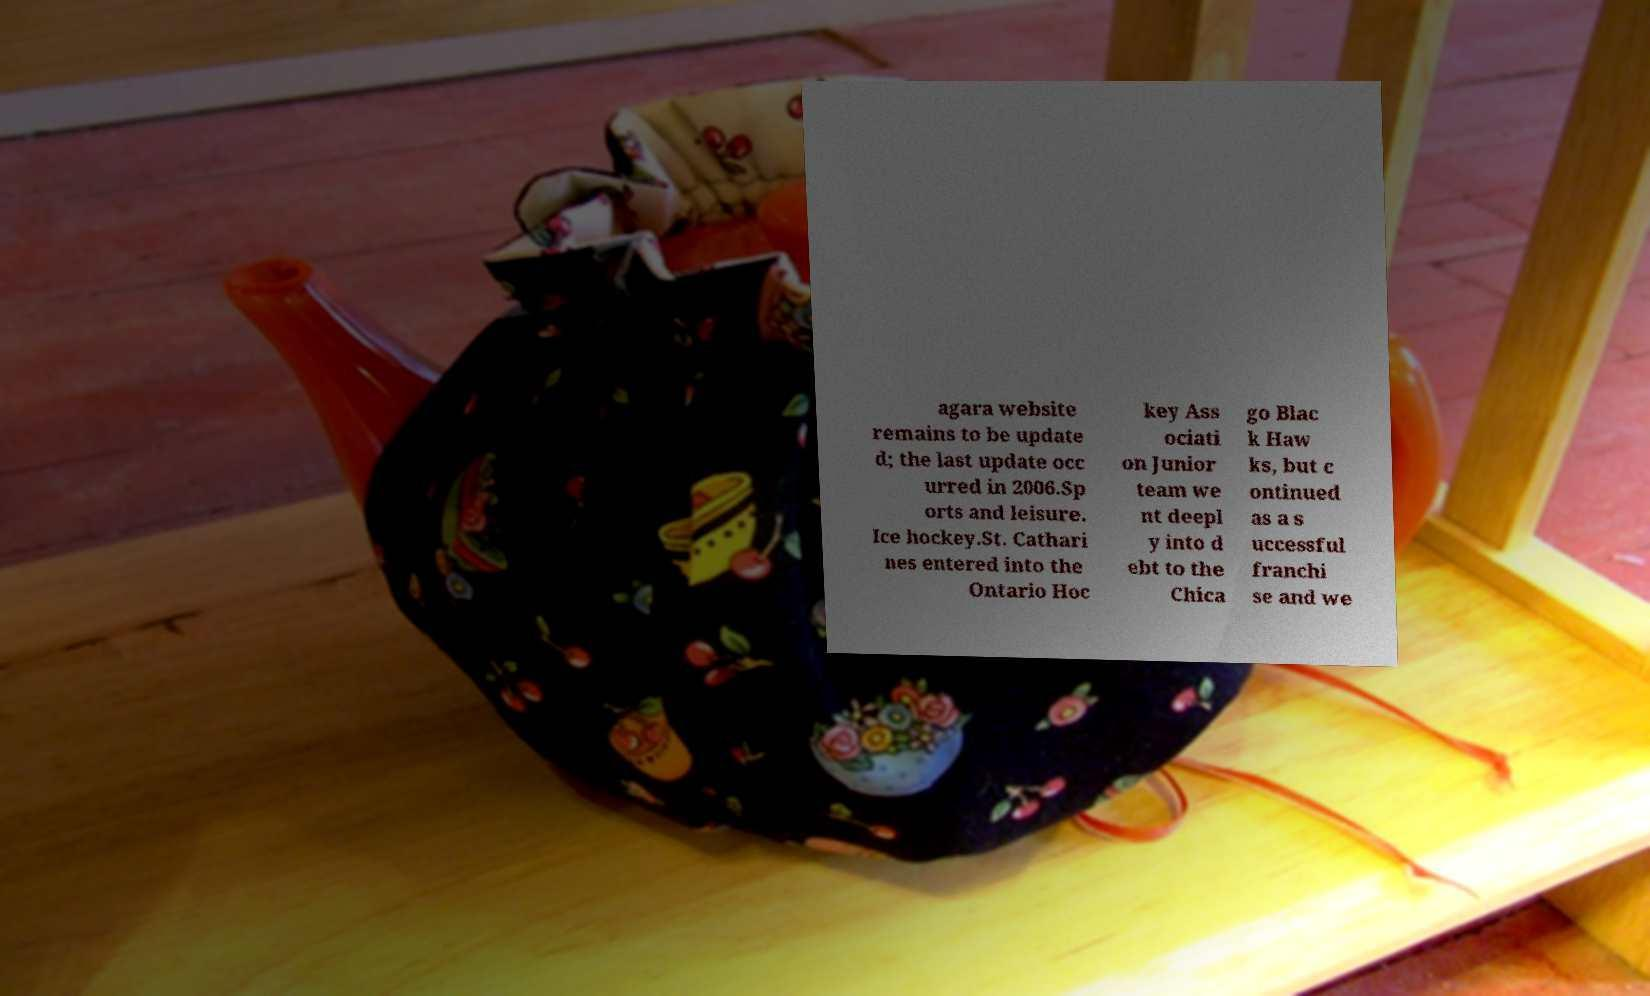What messages or text are displayed in this image? I need them in a readable, typed format. agara website remains to be update d; the last update occ urred in 2006.Sp orts and leisure. Ice hockey.St. Cathari nes entered into the Ontario Hoc key Ass ociati on Junior team we nt deepl y into d ebt to the Chica go Blac k Haw ks, but c ontinued as a s uccessful franchi se and we 